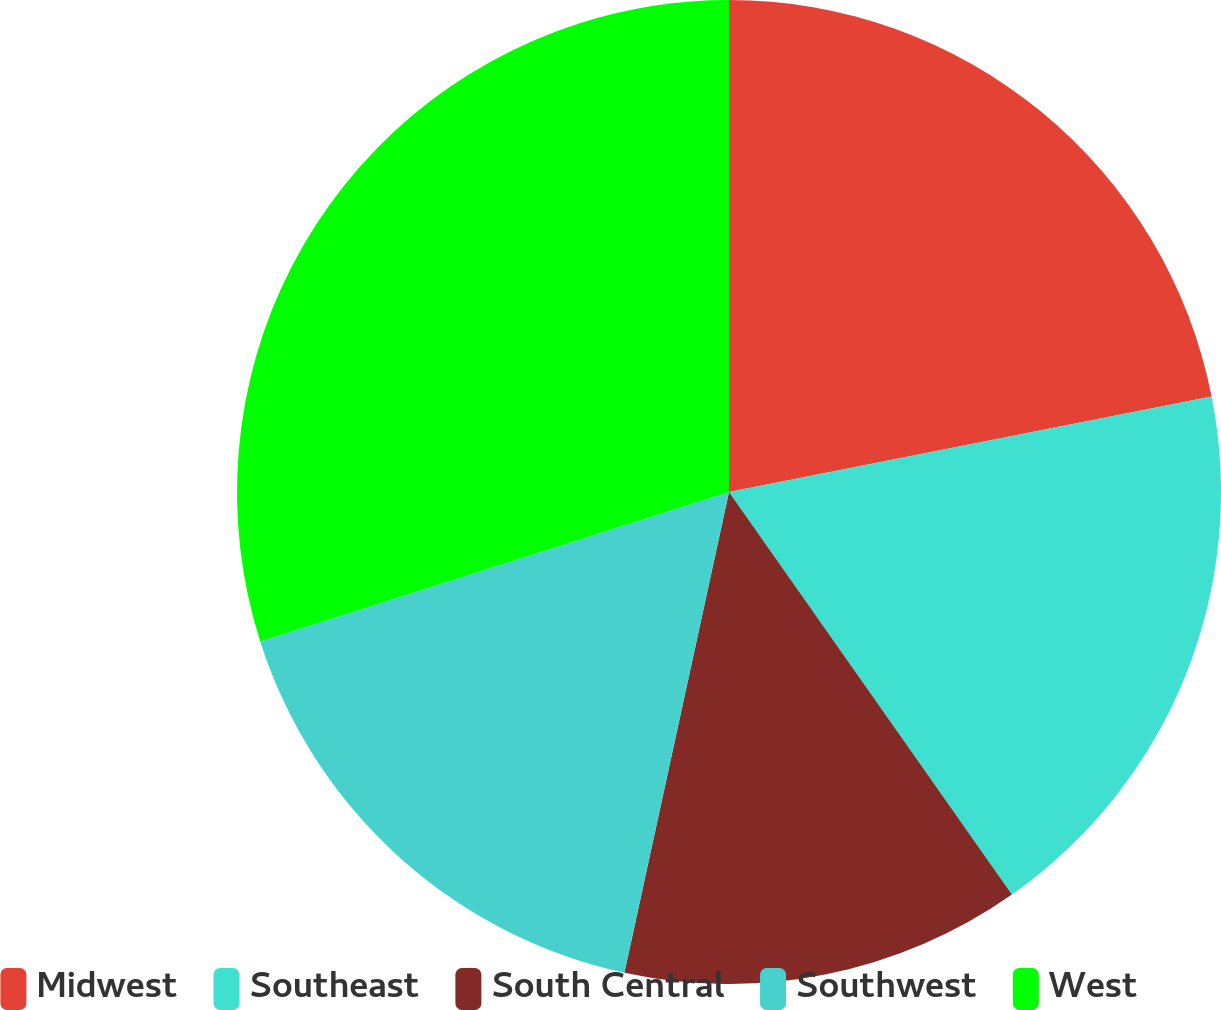Convert chart to OTSL. <chart><loc_0><loc_0><loc_500><loc_500><pie_chart><fcel>Midwest<fcel>Southeast<fcel>South Central<fcel>Southwest<fcel>West<nl><fcel>21.89%<fcel>18.36%<fcel>13.16%<fcel>16.68%<fcel>29.91%<nl></chart> 